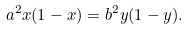<formula> <loc_0><loc_0><loc_500><loc_500>a ^ { 2 } x ( 1 - x ) = b ^ { 2 } y ( 1 - y ) .</formula> 